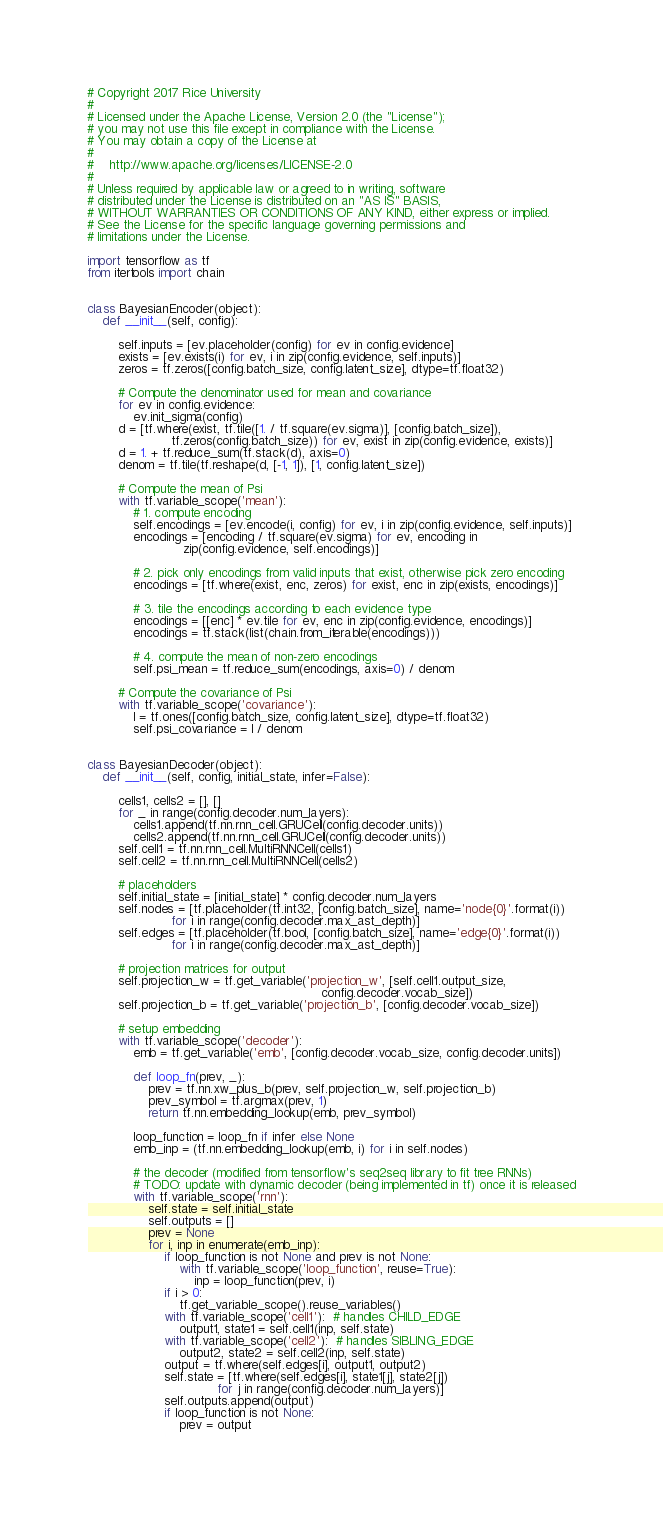Convert code to text. <code><loc_0><loc_0><loc_500><loc_500><_Python_># Copyright 2017 Rice University
#
# Licensed under the Apache License, Version 2.0 (the "License");
# you may not use this file except in compliance with the License.
# You may obtain a copy of the License at
#
#    http://www.apache.org/licenses/LICENSE-2.0
#
# Unless required by applicable law or agreed to in writing, software
# distributed under the License is distributed on an "AS IS" BASIS,
# WITHOUT WARRANTIES OR CONDITIONS OF ANY KIND, either express or implied.
# See the License for the specific language governing permissions and
# limitations under the License.

import tensorflow as tf
from itertools import chain


class BayesianEncoder(object):
    def __init__(self, config):

        self.inputs = [ev.placeholder(config) for ev in config.evidence]
        exists = [ev.exists(i) for ev, i in zip(config.evidence, self.inputs)]
        zeros = tf.zeros([config.batch_size, config.latent_size], dtype=tf.float32)

        # Compute the denominator used for mean and covariance
        for ev in config.evidence:
            ev.init_sigma(config)
        d = [tf.where(exist, tf.tile([1. / tf.square(ev.sigma)], [config.batch_size]),
                      tf.zeros(config.batch_size)) for ev, exist in zip(config.evidence, exists)]
        d = 1. + tf.reduce_sum(tf.stack(d), axis=0)
        denom = tf.tile(tf.reshape(d, [-1, 1]), [1, config.latent_size])

        # Compute the mean of Psi
        with tf.variable_scope('mean'):
            # 1. compute encoding
            self.encodings = [ev.encode(i, config) for ev, i in zip(config.evidence, self.inputs)]
            encodings = [encoding / tf.square(ev.sigma) for ev, encoding in
                         zip(config.evidence, self.encodings)]

            # 2. pick only encodings from valid inputs that exist, otherwise pick zero encoding
            encodings = [tf.where(exist, enc, zeros) for exist, enc in zip(exists, encodings)]

            # 3. tile the encodings according to each evidence type
            encodings = [[enc] * ev.tile for ev, enc in zip(config.evidence, encodings)]
            encodings = tf.stack(list(chain.from_iterable(encodings)))

            # 4. compute the mean of non-zero encodings
            self.psi_mean = tf.reduce_sum(encodings, axis=0) / denom

        # Compute the covariance of Psi
        with tf.variable_scope('covariance'):
            I = tf.ones([config.batch_size, config.latent_size], dtype=tf.float32)
            self.psi_covariance = I / denom


class BayesianDecoder(object):
    def __init__(self, config, initial_state, infer=False):

        cells1, cells2 = [], []
        for _ in range(config.decoder.num_layers):
            cells1.append(tf.nn.rnn_cell.GRUCell(config.decoder.units))
            cells2.append(tf.nn.rnn_cell.GRUCell(config.decoder.units))
        self.cell1 = tf.nn.rnn_cell.MultiRNNCell(cells1)
        self.cell2 = tf.nn.rnn_cell.MultiRNNCell(cells2)

        # placeholders
        self.initial_state = [initial_state] * config.decoder.num_layers
        self.nodes = [tf.placeholder(tf.int32, [config.batch_size], name='node{0}'.format(i))
                      for i in range(config.decoder.max_ast_depth)]
        self.edges = [tf.placeholder(tf.bool, [config.batch_size], name='edge{0}'.format(i))
                      for i in range(config.decoder.max_ast_depth)]

        # projection matrices for output
        self.projection_w = tf.get_variable('projection_w', [self.cell1.output_size,
                                                             config.decoder.vocab_size])
        self.projection_b = tf.get_variable('projection_b', [config.decoder.vocab_size])

        # setup embedding
        with tf.variable_scope('decoder'):
            emb = tf.get_variable('emb', [config.decoder.vocab_size, config.decoder.units])

            def loop_fn(prev, _):
                prev = tf.nn.xw_plus_b(prev, self.projection_w, self.projection_b)
                prev_symbol = tf.argmax(prev, 1)
                return tf.nn.embedding_lookup(emb, prev_symbol)

            loop_function = loop_fn if infer else None
            emb_inp = (tf.nn.embedding_lookup(emb, i) for i in self.nodes)

            # the decoder (modified from tensorflow's seq2seq library to fit tree RNNs)
            # TODO: update with dynamic decoder (being implemented in tf) once it is released
            with tf.variable_scope('rnn'):
                self.state = self.initial_state
                self.outputs = []
                prev = None
                for i, inp in enumerate(emb_inp):
                    if loop_function is not None and prev is not None:
                        with tf.variable_scope('loop_function', reuse=True):
                            inp = loop_function(prev, i)
                    if i > 0:
                        tf.get_variable_scope().reuse_variables()
                    with tf.variable_scope('cell1'):  # handles CHILD_EDGE
                        output1, state1 = self.cell1(inp, self.state)
                    with tf.variable_scope('cell2'):  # handles SIBLING_EDGE
                        output2, state2 = self.cell2(inp, self.state)
                    output = tf.where(self.edges[i], output1, output2)
                    self.state = [tf.where(self.edges[i], state1[j], state2[j])
                                  for j in range(config.decoder.num_layers)]
                    self.outputs.append(output)
                    if loop_function is not None:
                        prev = output
</code> 